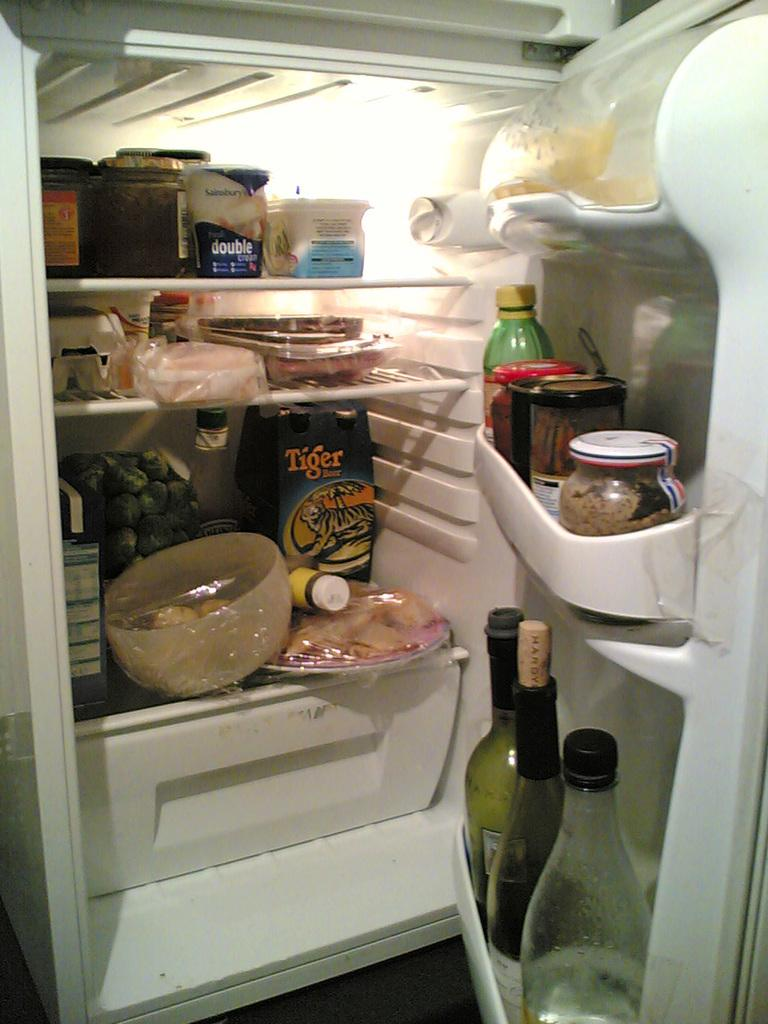<image>
Write a terse but informative summary of the picture. A package labeled "Tiger" sits on the lower shelf of a very full refrigerator. 